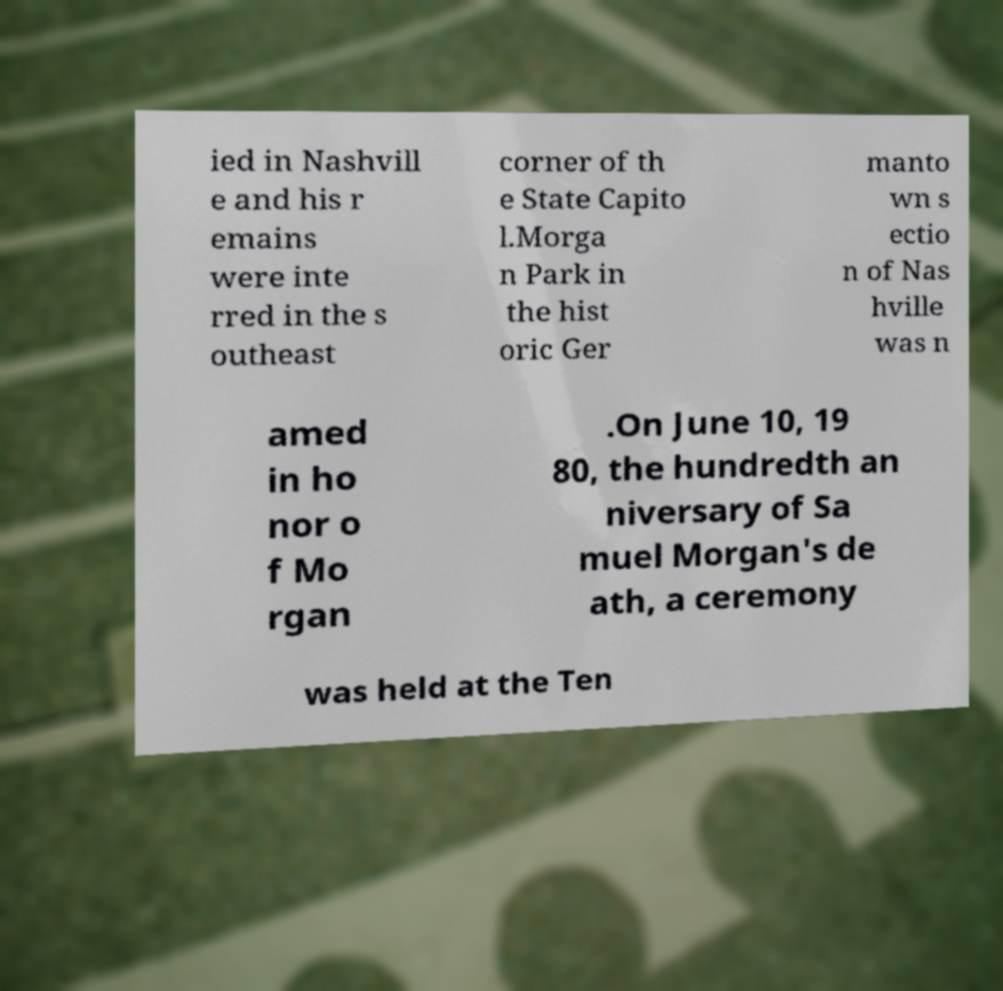For documentation purposes, I need the text within this image transcribed. Could you provide that? ied in Nashvill e and his r emains were inte rred in the s outheast corner of th e State Capito l.Morga n Park in the hist oric Ger manto wn s ectio n of Nas hville was n amed in ho nor o f Mo rgan .On June 10, 19 80, the hundredth an niversary of Sa muel Morgan's de ath, a ceremony was held at the Ten 